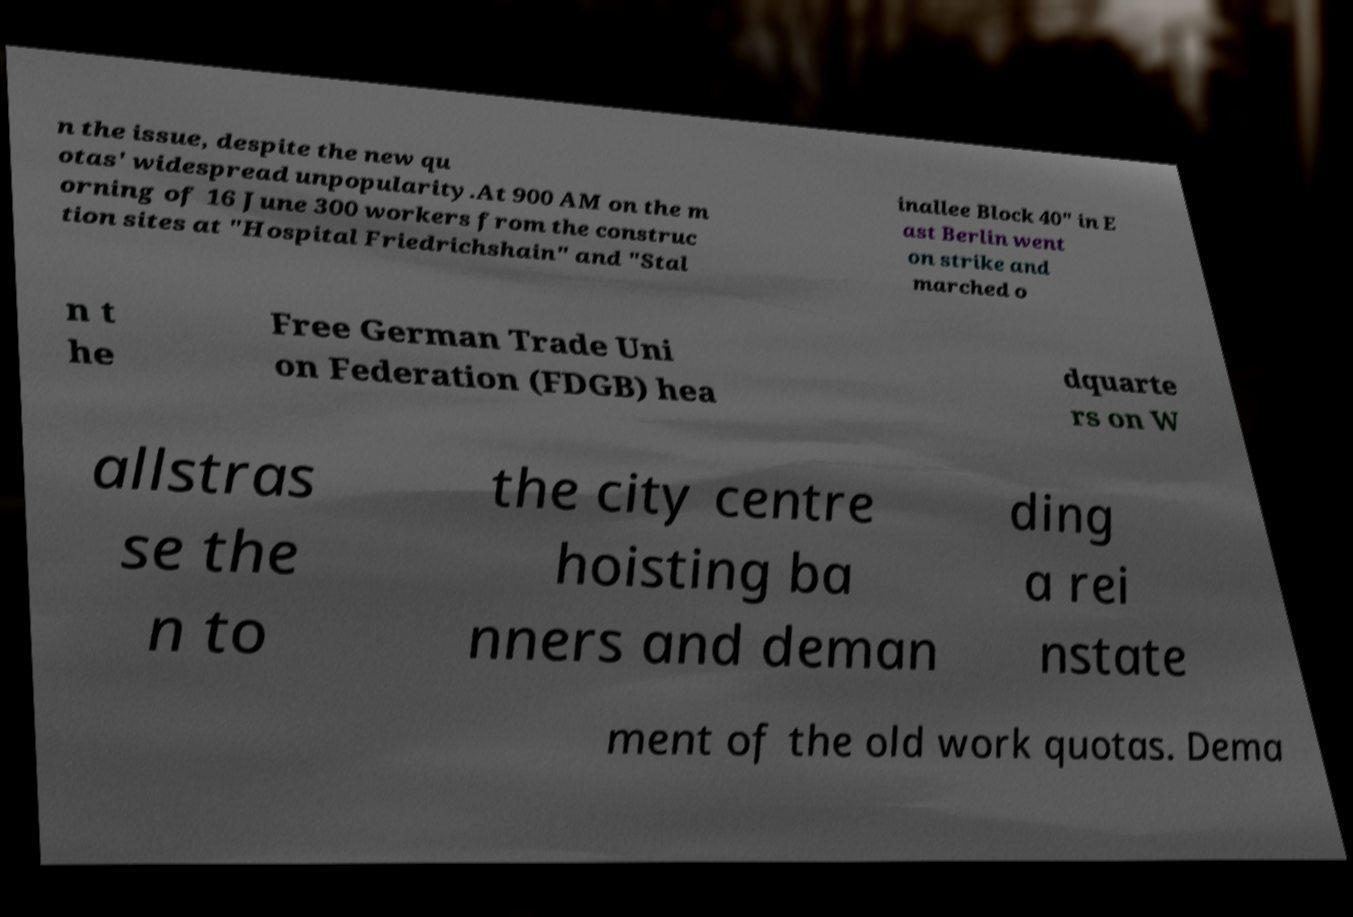Can you read and provide the text displayed in the image?This photo seems to have some interesting text. Can you extract and type it out for me? n the issue, despite the new qu otas' widespread unpopularity.At 900 AM on the m orning of 16 June 300 workers from the construc tion sites at "Hospital Friedrichshain" and "Stal inallee Block 40" in E ast Berlin went on strike and marched o n t he Free German Trade Uni on Federation (FDGB) hea dquarte rs on W allstras se the n to the city centre hoisting ba nners and deman ding a rei nstate ment of the old work quotas. Dema 